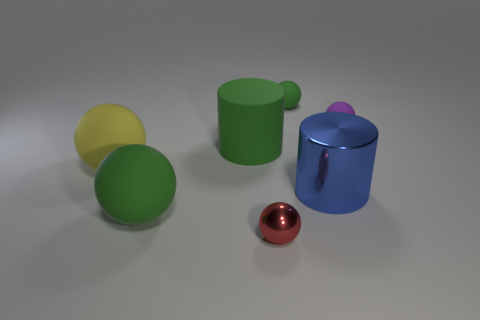There is a blue object; is its shape the same as the big green thing behind the blue cylinder?
Offer a terse response. Yes. How many small things are metallic cylinders or metallic balls?
Ensure brevity in your answer.  1. Is there a blue cylinder of the same size as the blue shiny object?
Keep it short and to the point. No. What is the color of the tiny ball that is in front of the green matte sphere in front of the green matte object behind the purple matte ball?
Provide a short and direct response. Red. Is the material of the small green ball the same as the yellow ball left of the tiny purple matte thing?
Your answer should be very brief. Yes. There is another object that is the same shape as the big metallic thing; what is its size?
Your answer should be compact. Large. Are there the same number of balls behind the shiny cylinder and cylinders to the right of the small purple object?
Offer a terse response. No. How many other objects are the same material as the big yellow sphere?
Keep it short and to the point. 4. Is the number of shiny things behind the yellow rubber object the same as the number of big red metallic things?
Provide a short and direct response. Yes. There is a matte cylinder; is it the same size as the green ball that is in front of the green cylinder?
Offer a terse response. Yes. 